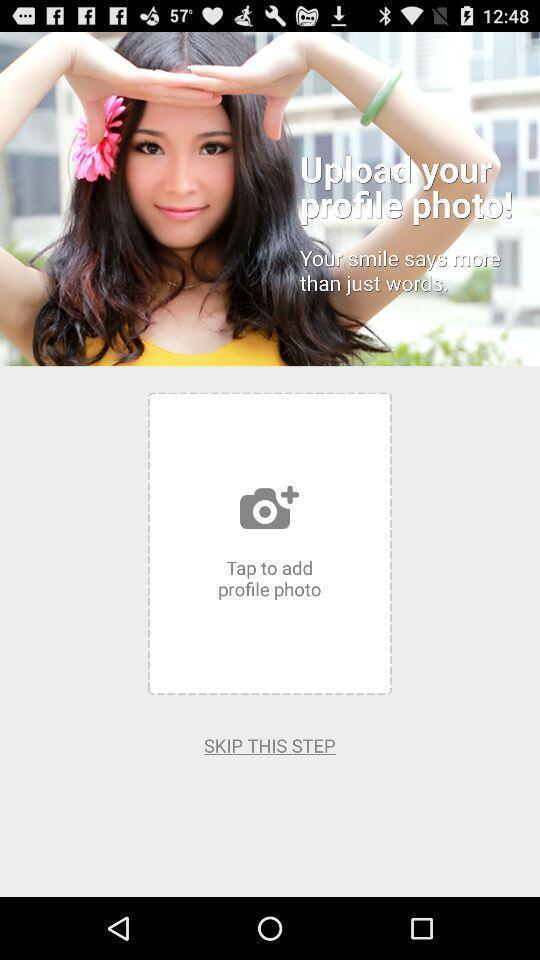Provide a detailed account of this screenshot. Page showing tap to add profile photo. 